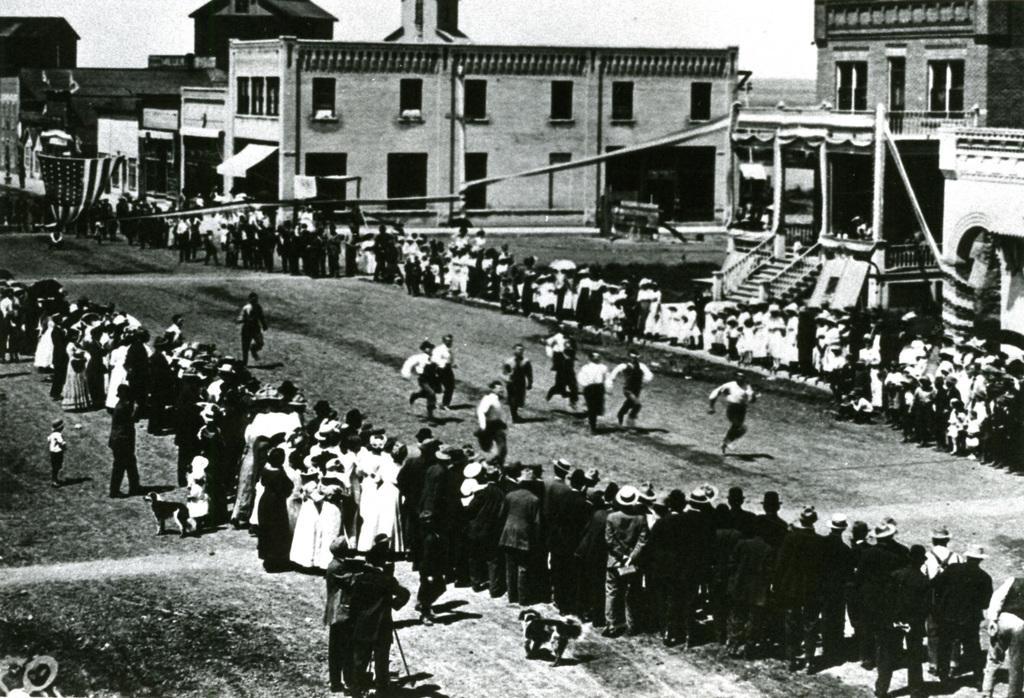How would you summarize this image in a sentence or two? In this black and white image there are a few people running on the ground, on the other sides of them there are so many spectators. In the background there are buildings and a sky. 